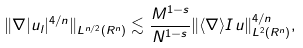<formula> <loc_0><loc_0><loc_500><loc_500>\| \nabla | u _ { l } | ^ { 4 / n } \| _ { L ^ { n / 2 } ( R ^ { n } ) } \lesssim \frac { M ^ { 1 - s } } { N ^ { 1 - s } } \| \langle \nabla \rangle I u \| _ { L ^ { 2 } ( R ^ { n } ) } ^ { 4 / n } ,</formula> 